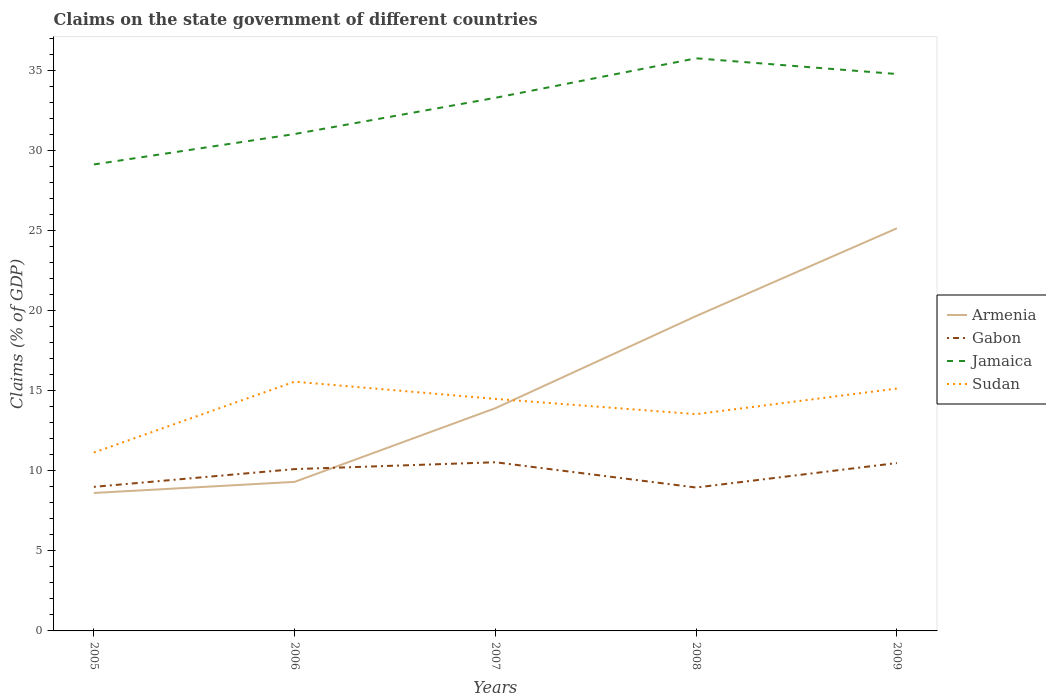Across all years, what is the maximum percentage of GDP claimed on the state government in Armenia?
Offer a terse response. 8.62. In which year was the percentage of GDP claimed on the state government in Sudan maximum?
Offer a very short reply. 2005. What is the total percentage of GDP claimed on the state government in Gabon in the graph?
Offer a terse response. -0.38. What is the difference between the highest and the second highest percentage of GDP claimed on the state government in Jamaica?
Provide a short and direct response. 6.63. Is the percentage of GDP claimed on the state government in Armenia strictly greater than the percentage of GDP claimed on the state government in Gabon over the years?
Keep it short and to the point. No. How many years are there in the graph?
Keep it short and to the point. 5. What is the difference between two consecutive major ticks on the Y-axis?
Offer a very short reply. 5. Does the graph contain any zero values?
Provide a succinct answer. No. Does the graph contain grids?
Provide a short and direct response. No. How are the legend labels stacked?
Make the answer very short. Vertical. What is the title of the graph?
Ensure brevity in your answer.  Claims on the state government of different countries. What is the label or title of the X-axis?
Your response must be concise. Years. What is the label or title of the Y-axis?
Your answer should be very brief. Claims (% of GDP). What is the Claims (% of GDP) in Armenia in 2005?
Give a very brief answer. 8.62. What is the Claims (% of GDP) of Gabon in 2005?
Your response must be concise. 9. What is the Claims (% of GDP) of Jamaica in 2005?
Give a very brief answer. 29.13. What is the Claims (% of GDP) in Sudan in 2005?
Provide a short and direct response. 11.14. What is the Claims (% of GDP) in Armenia in 2006?
Ensure brevity in your answer.  9.31. What is the Claims (% of GDP) of Gabon in 2006?
Offer a very short reply. 10.11. What is the Claims (% of GDP) in Jamaica in 2006?
Give a very brief answer. 31.03. What is the Claims (% of GDP) of Sudan in 2006?
Provide a succinct answer. 15.57. What is the Claims (% of GDP) of Armenia in 2007?
Provide a succinct answer. 13.91. What is the Claims (% of GDP) in Gabon in 2007?
Make the answer very short. 10.53. What is the Claims (% of GDP) of Jamaica in 2007?
Your response must be concise. 33.3. What is the Claims (% of GDP) in Sudan in 2007?
Offer a terse response. 14.49. What is the Claims (% of GDP) of Armenia in 2008?
Your response must be concise. 19.66. What is the Claims (% of GDP) of Gabon in 2008?
Give a very brief answer. 8.96. What is the Claims (% of GDP) of Jamaica in 2008?
Make the answer very short. 35.76. What is the Claims (% of GDP) of Sudan in 2008?
Your answer should be compact. 13.54. What is the Claims (% of GDP) of Armenia in 2009?
Ensure brevity in your answer.  25.15. What is the Claims (% of GDP) in Gabon in 2009?
Offer a terse response. 10.48. What is the Claims (% of GDP) in Jamaica in 2009?
Make the answer very short. 34.78. What is the Claims (% of GDP) of Sudan in 2009?
Offer a very short reply. 15.14. Across all years, what is the maximum Claims (% of GDP) in Armenia?
Keep it short and to the point. 25.15. Across all years, what is the maximum Claims (% of GDP) of Gabon?
Your answer should be very brief. 10.53. Across all years, what is the maximum Claims (% of GDP) of Jamaica?
Give a very brief answer. 35.76. Across all years, what is the maximum Claims (% of GDP) of Sudan?
Give a very brief answer. 15.57. Across all years, what is the minimum Claims (% of GDP) of Armenia?
Your response must be concise. 8.62. Across all years, what is the minimum Claims (% of GDP) of Gabon?
Your response must be concise. 8.96. Across all years, what is the minimum Claims (% of GDP) of Jamaica?
Your response must be concise. 29.13. Across all years, what is the minimum Claims (% of GDP) in Sudan?
Your response must be concise. 11.14. What is the total Claims (% of GDP) of Armenia in the graph?
Make the answer very short. 76.65. What is the total Claims (% of GDP) in Gabon in the graph?
Your answer should be very brief. 49.08. What is the total Claims (% of GDP) of Jamaica in the graph?
Provide a short and direct response. 164.01. What is the total Claims (% of GDP) in Sudan in the graph?
Keep it short and to the point. 69.87. What is the difference between the Claims (% of GDP) of Armenia in 2005 and that in 2006?
Give a very brief answer. -0.69. What is the difference between the Claims (% of GDP) in Gabon in 2005 and that in 2006?
Offer a very short reply. -1.11. What is the difference between the Claims (% of GDP) of Jamaica in 2005 and that in 2006?
Offer a terse response. -1.9. What is the difference between the Claims (% of GDP) in Sudan in 2005 and that in 2006?
Provide a succinct answer. -4.43. What is the difference between the Claims (% of GDP) of Armenia in 2005 and that in 2007?
Your answer should be compact. -5.3. What is the difference between the Claims (% of GDP) of Gabon in 2005 and that in 2007?
Your answer should be very brief. -1.54. What is the difference between the Claims (% of GDP) of Jamaica in 2005 and that in 2007?
Your answer should be very brief. -4.16. What is the difference between the Claims (% of GDP) in Sudan in 2005 and that in 2007?
Keep it short and to the point. -3.35. What is the difference between the Claims (% of GDP) of Armenia in 2005 and that in 2008?
Offer a terse response. -11.05. What is the difference between the Claims (% of GDP) of Gabon in 2005 and that in 2008?
Offer a very short reply. 0.04. What is the difference between the Claims (% of GDP) in Jamaica in 2005 and that in 2008?
Ensure brevity in your answer.  -6.63. What is the difference between the Claims (% of GDP) in Sudan in 2005 and that in 2008?
Provide a short and direct response. -2.4. What is the difference between the Claims (% of GDP) in Armenia in 2005 and that in 2009?
Ensure brevity in your answer.  -16.53. What is the difference between the Claims (% of GDP) of Gabon in 2005 and that in 2009?
Make the answer very short. -1.49. What is the difference between the Claims (% of GDP) in Jamaica in 2005 and that in 2009?
Make the answer very short. -5.65. What is the difference between the Claims (% of GDP) of Sudan in 2005 and that in 2009?
Offer a very short reply. -4. What is the difference between the Claims (% of GDP) in Armenia in 2006 and that in 2007?
Give a very brief answer. -4.6. What is the difference between the Claims (% of GDP) in Gabon in 2006 and that in 2007?
Provide a succinct answer. -0.43. What is the difference between the Claims (% of GDP) in Jamaica in 2006 and that in 2007?
Keep it short and to the point. -2.26. What is the difference between the Claims (% of GDP) in Sudan in 2006 and that in 2007?
Ensure brevity in your answer.  1.08. What is the difference between the Claims (% of GDP) in Armenia in 2006 and that in 2008?
Keep it short and to the point. -10.36. What is the difference between the Claims (% of GDP) of Gabon in 2006 and that in 2008?
Your answer should be compact. 1.15. What is the difference between the Claims (% of GDP) in Jamaica in 2006 and that in 2008?
Make the answer very short. -4.73. What is the difference between the Claims (% of GDP) in Sudan in 2006 and that in 2008?
Offer a very short reply. 2.03. What is the difference between the Claims (% of GDP) of Armenia in 2006 and that in 2009?
Provide a short and direct response. -15.84. What is the difference between the Claims (% of GDP) in Gabon in 2006 and that in 2009?
Your answer should be compact. -0.38. What is the difference between the Claims (% of GDP) in Jamaica in 2006 and that in 2009?
Your answer should be compact. -3.75. What is the difference between the Claims (% of GDP) of Sudan in 2006 and that in 2009?
Your answer should be very brief. 0.43. What is the difference between the Claims (% of GDP) of Armenia in 2007 and that in 2008?
Offer a terse response. -5.75. What is the difference between the Claims (% of GDP) of Gabon in 2007 and that in 2008?
Your answer should be compact. 1.58. What is the difference between the Claims (% of GDP) in Jamaica in 2007 and that in 2008?
Your answer should be very brief. -2.47. What is the difference between the Claims (% of GDP) in Sudan in 2007 and that in 2008?
Give a very brief answer. 0.95. What is the difference between the Claims (% of GDP) of Armenia in 2007 and that in 2009?
Offer a very short reply. -11.23. What is the difference between the Claims (% of GDP) in Gabon in 2007 and that in 2009?
Your response must be concise. 0.05. What is the difference between the Claims (% of GDP) in Jamaica in 2007 and that in 2009?
Keep it short and to the point. -1.49. What is the difference between the Claims (% of GDP) in Sudan in 2007 and that in 2009?
Offer a very short reply. -0.65. What is the difference between the Claims (% of GDP) of Armenia in 2008 and that in 2009?
Offer a very short reply. -5.48. What is the difference between the Claims (% of GDP) of Gabon in 2008 and that in 2009?
Offer a terse response. -1.53. What is the difference between the Claims (% of GDP) of Jamaica in 2008 and that in 2009?
Offer a terse response. 0.98. What is the difference between the Claims (% of GDP) of Sudan in 2008 and that in 2009?
Provide a short and direct response. -1.6. What is the difference between the Claims (% of GDP) in Armenia in 2005 and the Claims (% of GDP) in Gabon in 2006?
Make the answer very short. -1.49. What is the difference between the Claims (% of GDP) of Armenia in 2005 and the Claims (% of GDP) of Jamaica in 2006?
Make the answer very short. -22.42. What is the difference between the Claims (% of GDP) of Armenia in 2005 and the Claims (% of GDP) of Sudan in 2006?
Your answer should be very brief. -6.95. What is the difference between the Claims (% of GDP) in Gabon in 2005 and the Claims (% of GDP) in Jamaica in 2006?
Your answer should be compact. -22.04. What is the difference between the Claims (% of GDP) of Gabon in 2005 and the Claims (% of GDP) of Sudan in 2006?
Offer a terse response. -6.57. What is the difference between the Claims (% of GDP) in Jamaica in 2005 and the Claims (% of GDP) in Sudan in 2006?
Your answer should be very brief. 13.57. What is the difference between the Claims (% of GDP) in Armenia in 2005 and the Claims (% of GDP) in Gabon in 2007?
Your answer should be very brief. -1.92. What is the difference between the Claims (% of GDP) of Armenia in 2005 and the Claims (% of GDP) of Jamaica in 2007?
Provide a short and direct response. -24.68. What is the difference between the Claims (% of GDP) in Armenia in 2005 and the Claims (% of GDP) in Sudan in 2007?
Offer a terse response. -5.88. What is the difference between the Claims (% of GDP) of Gabon in 2005 and the Claims (% of GDP) of Jamaica in 2007?
Your answer should be very brief. -24.3. What is the difference between the Claims (% of GDP) of Gabon in 2005 and the Claims (% of GDP) of Sudan in 2007?
Your answer should be compact. -5.49. What is the difference between the Claims (% of GDP) in Jamaica in 2005 and the Claims (% of GDP) in Sudan in 2007?
Provide a short and direct response. 14.64. What is the difference between the Claims (% of GDP) of Armenia in 2005 and the Claims (% of GDP) of Gabon in 2008?
Your response must be concise. -0.34. What is the difference between the Claims (% of GDP) in Armenia in 2005 and the Claims (% of GDP) in Jamaica in 2008?
Provide a succinct answer. -27.15. What is the difference between the Claims (% of GDP) of Armenia in 2005 and the Claims (% of GDP) of Sudan in 2008?
Your answer should be very brief. -4.92. What is the difference between the Claims (% of GDP) in Gabon in 2005 and the Claims (% of GDP) in Jamaica in 2008?
Ensure brevity in your answer.  -26.77. What is the difference between the Claims (% of GDP) in Gabon in 2005 and the Claims (% of GDP) in Sudan in 2008?
Your response must be concise. -4.54. What is the difference between the Claims (% of GDP) of Jamaica in 2005 and the Claims (% of GDP) of Sudan in 2008?
Your answer should be very brief. 15.6. What is the difference between the Claims (% of GDP) of Armenia in 2005 and the Claims (% of GDP) of Gabon in 2009?
Keep it short and to the point. -1.87. What is the difference between the Claims (% of GDP) of Armenia in 2005 and the Claims (% of GDP) of Jamaica in 2009?
Provide a short and direct response. -26.17. What is the difference between the Claims (% of GDP) in Armenia in 2005 and the Claims (% of GDP) in Sudan in 2009?
Offer a very short reply. -6.52. What is the difference between the Claims (% of GDP) of Gabon in 2005 and the Claims (% of GDP) of Jamaica in 2009?
Provide a succinct answer. -25.78. What is the difference between the Claims (% of GDP) in Gabon in 2005 and the Claims (% of GDP) in Sudan in 2009?
Your answer should be very brief. -6.14. What is the difference between the Claims (% of GDP) in Jamaica in 2005 and the Claims (% of GDP) in Sudan in 2009?
Provide a short and direct response. 14. What is the difference between the Claims (% of GDP) in Armenia in 2006 and the Claims (% of GDP) in Gabon in 2007?
Make the answer very short. -1.23. What is the difference between the Claims (% of GDP) of Armenia in 2006 and the Claims (% of GDP) of Jamaica in 2007?
Offer a very short reply. -23.99. What is the difference between the Claims (% of GDP) in Armenia in 2006 and the Claims (% of GDP) in Sudan in 2007?
Keep it short and to the point. -5.18. What is the difference between the Claims (% of GDP) of Gabon in 2006 and the Claims (% of GDP) of Jamaica in 2007?
Your answer should be very brief. -23.19. What is the difference between the Claims (% of GDP) of Gabon in 2006 and the Claims (% of GDP) of Sudan in 2007?
Provide a short and direct response. -4.38. What is the difference between the Claims (% of GDP) of Jamaica in 2006 and the Claims (% of GDP) of Sudan in 2007?
Offer a terse response. 16.54. What is the difference between the Claims (% of GDP) in Armenia in 2006 and the Claims (% of GDP) in Gabon in 2008?
Offer a terse response. 0.35. What is the difference between the Claims (% of GDP) of Armenia in 2006 and the Claims (% of GDP) of Jamaica in 2008?
Your response must be concise. -26.45. What is the difference between the Claims (% of GDP) in Armenia in 2006 and the Claims (% of GDP) in Sudan in 2008?
Your answer should be very brief. -4.23. What is the difference between the Claims (% of GDP) in Gabon in 2006 and the Claims (% of GDP) in Jamaica in 2008?
Provide a succinct answer. -25.66. What is the difference between the Claims (% of GDP) in Gabon in 2006 and the Claims (% of GDP) in Sudan in 2008?
Offer a very short reply. -3.43. What is the difference between the Claims (% of GDP) in Jamaica in 2006 and the Claims (% of GDP) in Sudan in 2008?
Make the answer very short. 17.5. What is the difference between the Claims (% of GDP) of Armenia in 2006 and the Claims (% of GDP) of Gabon in 2009?
Provide a succinct answer. -1.18. What is the difference between the Claims (% of GDP) in Armenia in 2006 and the Claims (% of GDP) in Jamaica in 2009?
Your answer should be compact. -25.47. What is the difference between the Claims (% of GDP) in Armenia in 2006 and the Claims (% of GDP) in Sudan in 2009?
Your response must be concise. -5.83. What is the difference between the Claims (% of GDP) of Gabon in 2006 and the Claims (% of GDP) of Jamaica in 2009?
Offer a very short reply. -24.67. What is the difference between the Claims (% of GDP) of Gabon in 2006 and the Claims (% of GDP) of Sudan in 2009?
Offer a terse response. -5.03. What is the difference between the Claims (% of GDP) in Jamaica in 2006 and the Claims (% of GDP) in Sudan in 2009?
Make the answer very short. 15.9. What is the difference between the Claims (% of GDP) in Armenia in 2007 and the Claims (% of GDP) in Gabon in 2008?
Your response must be concise. 4.96. What is the difference between the Claims (% of GDP) of Armenia in 2007 and the Claims (% of GDP) of Jamaica in 2008?
Offer a very short reply. -21.85. What is the difference between the Claims (% of GDP) of Armenia in 2007 and the Claims (% of GDP) of Sudan in 2008?
Keep it short and to the point. 0.37. What is the difference between the Claims (% of GDP) of Gabon in 2007 and the Claims (% of GDP) of Jamaica in 2008?
Your answer should be very brief. -25.23. What is the difference between the Claims (% of GDP) of Gabon in 2007 and the Claims (% of GDP) of Sudan in 2008?
Keep it short and to the point. -3. What is the difference between the Claims (% of GDP) in Jamaica in 2007 and the Claims (% of GDP) in Sudan in 2008?
Your response must be concise. 19.76. What is the difference between the Claims (% of GDP) of Armenia in 2007 and the Claims (% of GDP) of Gabon in 2009?
Provide a short and direct response. 3.43. What is the difference between the Claims (% of GDP) of Armenia in 2007 and the Claims (% of GDP) of Jamaica in 2009?
Keep it short and to the point. -20.87. What is the difference between the Claims (% of GDP) in Armenia in 2007 and the Claims (% of GDP) in Sudan in 2009?
Your response must be concise. -1.23. What is the difference between the Claims (% of GDP) of Gabon in 2007 and the Claims (% of GDP) of Jamaica in 2009?
Your response must be concise. -24.25. What is the difference between the Claims (% of GDP) of Gabon in 2007 and the Claims (% of GDP) of Sudan in 2009?
Offer a very short reply. -4.6. What is the difference between the Claims (% of GDP) of Jamaica in 2007 and the Claims (% of GDP) of Sudan in 2009?
Make the answer very short. 18.16. What is the difference between the Claims (% of GDP) in Armenia in 2008 and the Claims (% of GDP) in Gabon in 2009?
Make the answer very short. 9.18. What is the difference between the Claims (% of GDP) in Armenia in 2008 and the Claims (% of GDP) in Jamaica in 2009?
Your answer should be compact. -15.12. What is the difference between the Claims (% of GDP) of Armenia in 2008 and the Claims (% of GDP) of Sudan in 2009?
Give a very brief answer. 4.53. What is the difference between the Claims (% of GDP) of Gabon in 2008 and the Claims (% of GDP) of Jamaica in 2009?
Your answer should be very brief. -25.83. What is the difference between the Claims (% of GDP) in Gabon in 2008 and the Claims (% of GDP) in Sudan in 2009?
Offer a terse response. -6.18. What is the difference between the Claims (% of GDP) of Jamaica in 2008 and the Claims (% of GDP) of Sudan in 2009?
Keep it short and to the point. 20.63. What is the average Claims (% of GDP) of Armenia per year?
Your answer should be compact. 15.33. What is the average Claims (% of GDP) in Gabon per year?
Offer a terse response. 9.82. What is the average Claims (% of GDP) in Jamaica per year?
Ensure brevity in your answer.  32.8. What is the average Claims (% of GDP) in Sudan per year?
Offer a terse response. 13.97. In the year 2005, what is the difference between the Claims (% of GDP) in Armenia and Claims (% of GDP) in Gabon?
Your response must be concise. -0.38. In the year 2005, what is the difference between the Claims (% of GDP) of Armenia and Claims (% of GDP) of Jamaica?
Give a very brief answer. -20.52. In the year 2005, what is the difference between the Claims (% of GDP) of Armenia and Claims (% of GDP) of Sudan?
Give a very brief answer. -2.52. In the year 2005, what is the difference between the Claims (% of GDP) of Gabon and Claims (% of GDP) of Jamaica?
Your answer should be very brief. -20.14. In the year 2005, what is the difference between the Claims (% of GDP) in Gabon and Claims (% of GDP) in Sudan?
Offer a terse response. -2.14. In the year 2005, what is the difference between the Claims (% of GDP) of Jamaica and Claims (% of GDP) of Sudan?
Keep it short and to the point. 17.99. In the year 2006, what is the difference between the Claims (% of GDP) in Armenia and Claims (% of GDP) in Gabon?
Your response must be concise. -0.8. In the year 2006, what is the difference between the Claims (% of GDP) of Armenia and Claims (% of GDP) of Jamaica?
Offer a very short reply. -21.72. In the year 2006, what is the difference between the Claims (% of GDP) of Armenia and Claims (% of GDP) of Sudan?
Offer a very short reply. -6.26. In the year 2006, what is the difference between the Claims (% of GDP) in Gabon and Claims (% of GDP) in Jamaica?
Provide a short and direct response. -20.93. In the year 2006, what is the difference between the Claims (% of GDP) in Gabon and Claims (% of GDP) in Sudan?
Offer a very short reply. -5.46. In the year 2006, what is the difference between the Claims (% of GDP) in Jamaica and Claims (% of GDP) in Sudan?
Your answer should be compact. 15.47. In the year 2007, what is the difference between the Claims (% of GDP) in Armenia and Claims (% of GDP) in Gabon?
Give a very brief answer. 3.38. In the year 2007, what is the difference between the Claims (% of GDP) of Armenia and Claims (% of GDP) of Jamaica?
Offer a very short reply. -19.38. In the year 2007, what is the difference between the Claims (% of GDP) of Armenia and Claims (% of GDP) of Sudan?
Keep it short and to the point. -0.58. In the year 2007, what is the difference between the Claims (% of GDP) in Gabon and Claims (% of GDP) in Jamaica?
Your response must be concise. -22.76. In the year 2007, what is the difference between the Claims (% of GDP) of Gabon and Claims (% of GDP) of Sudan?
Your answer should be very brief. -3.96. In the year 2007, what is the difference between the Claims (% of GDP) in Jamaica and Claims (% of GDP) in Sudan?
Provide a succinct answer. 18.8. In the year 2008, what is the difference between the Claims (% of GDP) of Armenia and Claims (% of GDP) of Gabon?
Ensure brevity in your answer.  10.71. In the year 2008, what is the difference between the Claims (% of GDP) of Armenia and Claims (% of GDP) of Jamaica?
Your answer should be compact. -16.1. In the year 2008, what is the difference between the Claims (% of GDP) in Armenia and Claims (% of GDP) in Sudan?
Offer a terse response. 6.13. In the year 2008, what is the difference between the Claims (% of GDP) in Gabon and Claims (% of GDP) in Jamaica?
Your answer should be very brief. -26.81. In the year 2008, what is the difference between the Claims (% of GDP) in Gabon and Claims (% of GDP) in Sudan?
Make the answer very short. -4.58. In the year 2008, what is the difference between the Claims (% of GDP) of Jamaica and Claims (% of GDP) of Sudan?
Your answer should be very brief. 22.23. In the year 2009, what is the difference between the Claims (% of GDP) of Armenia and Claims (% of GDP) of Gabon?
Provide a short and direct response. 14.66. In the year 2009, what is the difference between the Claims (% of GDP) in Armenia and Claims (% of GDP) in Jamaica?
Provide a short and direct response. -9.64. In the year 2009, what is the difference between the Claims (% of GDP) of Armenia and Claims (% of GDP) of Sudan?
Your answer should be compact. 10.01. In the year 2009, what is the difference between the Claims (% of GDP) in Gabon and Claims (% of GDP) in Jamaica?
Make the answer very short. -24.3. In the year 2009, what is the difference between the Claims (% of GDP) in Gabon and Claims (% of GDP) in Sudan?
Offer a terse response. -4.65. In the year 2009, what is the difference between the Claims (% of GDP) of Jamaica and Claims (% of GDP) of Sudan?
Provide a short and direct response. 19.64. What is the ratio of the Claims (% of GDP) of Armenia in 2005 to that in 2006?
Your answer should be very brief. 0.93. What is the ratio of the Claims (% of GDP) in Gabon in 2005 to that in 2006?
Offer a terse response. 0.89. What is the ratio of the Claims (% of GDP) in Jamaica in 2005 to that in 2006?
Give a very brief answer. 0.94. What is the ratio of the Claims (% of GDP) in Sudan in 2005 to that in 2006?
Provide a succinct answer. 0.72. What is the ratio of the Claims (% of GDP) in Armenia in 2005 to that in 2007?
Provide a short and direct response. 0.62. What is the ratio of the Claims (% of GDP) of Gabon in 2005 to that in 2007?
Provide a short and direct response. 0.85. What is the ratio of the Claims (% of GDP) in Sudan in 2005 to that in 2007?
Make the answer very short. 0.77. What is the ratio of the Claims (% of GDP) in Armenia in 2005 to that in 2008?
Offer a very short reply. 0.44. What is the ratio of the Claims (% of GDP) in Gabon in 2005 to that in 2008?
Give a very brief answer. 1. What is the ratio of the Claims (% of GDP) of Jamaica in 2005 to that in 2008?
Make the answer very short. 0.81. What is the ratio of the Claims (% of GDP) of Sudan in 2005 to that in 2008?
Provide a succinct answer. 0.82. What is the ratio of the Claims (% of GDP) in Armenia in 2005 to that in 2009?
Keep it short and to the point. 0.34. What is the ratio of the Claims (% of GDP) of Gabon in 2005 to that in 2009?
Provide a short and direct response. 0.86. What is the ratio of the Claims (% of GDP) in Jamaica in 2005 to that in 2009?
Provide a short and direct response. 0.84. What is the ratio of the Claims (% of GDP) in Sudan in 2005 to that in 2009?
Provide a succinct answer. 0.74. What is the ratio of the Claims (% of GDP) of Armenia in 2006 to that in 2007?
Your response must be concise. 0.67. What is the ratio of the Claims (% of GDP) in Gabon in 2006 to that in 2007?
Your response must be concise. 0.96. What is the ratio of the Claims (% of GDP) of Jamaica in 2006 to that in 2007?
Give a very brief answer. 0.93. What is the ratio of the Claims (% of GDP) of Sudan in 2006 to that in 2007?
Provide a succinct answer. 1.07. What is the ratio of the Claims (% of GDP) in Armenia in 2006 to that in 2008?
Provide a short and direct response. 0.47. What is the ratio of the Claims (% of GDP) of Gabon in 2006 to that in 2008?
Provide a short and direct response. 1.13. What is the ratio of the Claims (% of GDP) of Jamaica in 2006 to that in 2008?
Your response must be concise. 0.87. What is the ratio of the Claims (% of GDP) of Sudan in 2006 to that in 2008?
Offer a very short reply. 1.15. What is the ratio of the Claims (% of GDP) in Armenia in 2006 to that in 2009?
Your response must be concise. 0.37. What is the ratio of the Claims (% of GDP) in Gabon in 2006 to that in 2009?
Give a very brief answer. 0.96. What is the ratio of the Claims (% of GDP) of Jamaica in 2006 to that in 2009?
Your response must be concise. 0.89. What is the ratio of the Claims (% of GDP) in Sudan in 2006 to that in 2009?
Keep it short and to the point. 1.03. What is the ratio of the Claims (% of GDP) of Armenia in 2007 to that in 2008?
Make the answer very short. 0.71. What is the ratio of the Claims (% of GDP) in Gabon in 2007 to that in 2008?
Your response must be concise. 1.18. What is the ratio of the Claims (% of GDP) of Sudan in 2007 to that in 2008?
Your response must be concise. 1.07. What is the ratio of the Claims (% of GDP) in Armenia in 2007 to that in 2009?
Ensure brevity in your answer.  0.55. What is the ratio of the Claims (% of GDP) of Gabon in 2007 to that in 2009?
Offer a very short reply. 1. What is the ratio of the Claims (% of GDP) of Jamaica in 2007 to that in 2009?
Ensure brevity in your answer.  0.96. What is the ratio of the Claims (% of GDP) in Sudan in 2007 to that in 2009?
Your answer should be very brief. 0.96. What is the ratio of the Claims (% of GDP) of Armenia in 2008 to that in 2009?
Offer a very short reply. 0.78. What is the ratio of the Claims (% of GDP) of Gabon in 2008 to that in 2009?
Make the answer very short. 0.85. What is the ratio of the Claims (% of GDP) in Jamaica in 2008 to that in 2009?
Your answer should be very brief. 1.03. What is the ratio of the Claims (% of GDP) in Sudan in 2008 to that in 2009?
Keep it short and to the point. 0.89. What is the difference between the highest and the second highest Claims (% of GDP) of Armenia?
Ensure brevity in your answer.  5.48. What is the difference between the highest and the second highest Claims (% of GDP) of Gabon?
Your response must be concise. 0.05. What is the difference between the highest and the second highest Claims (% of GDP) in Jamaica?
Give a very brief answer. 0.98. What is the difference between the highest and the second highest Claims (% of GDP) in Sudan?
Provide a short and direct response. 0.43. What is the difference between the highest and the lowest Claims (% of GDP) in Armenia?
Provide a succinct answer. 16.53. What is the difference between the highest and the lowest Claims (% of GDP) in Gabon?
Keep it short and to the point. 1.58. What is the difference between the highest and the lowest Claims (% of GDP) of Jamaica?
Your answer should be compact. 6.63. What is the difference between the highest and the lowest Claims (% of GDP) of Sudan?
Offer a terse response. 4.43. 